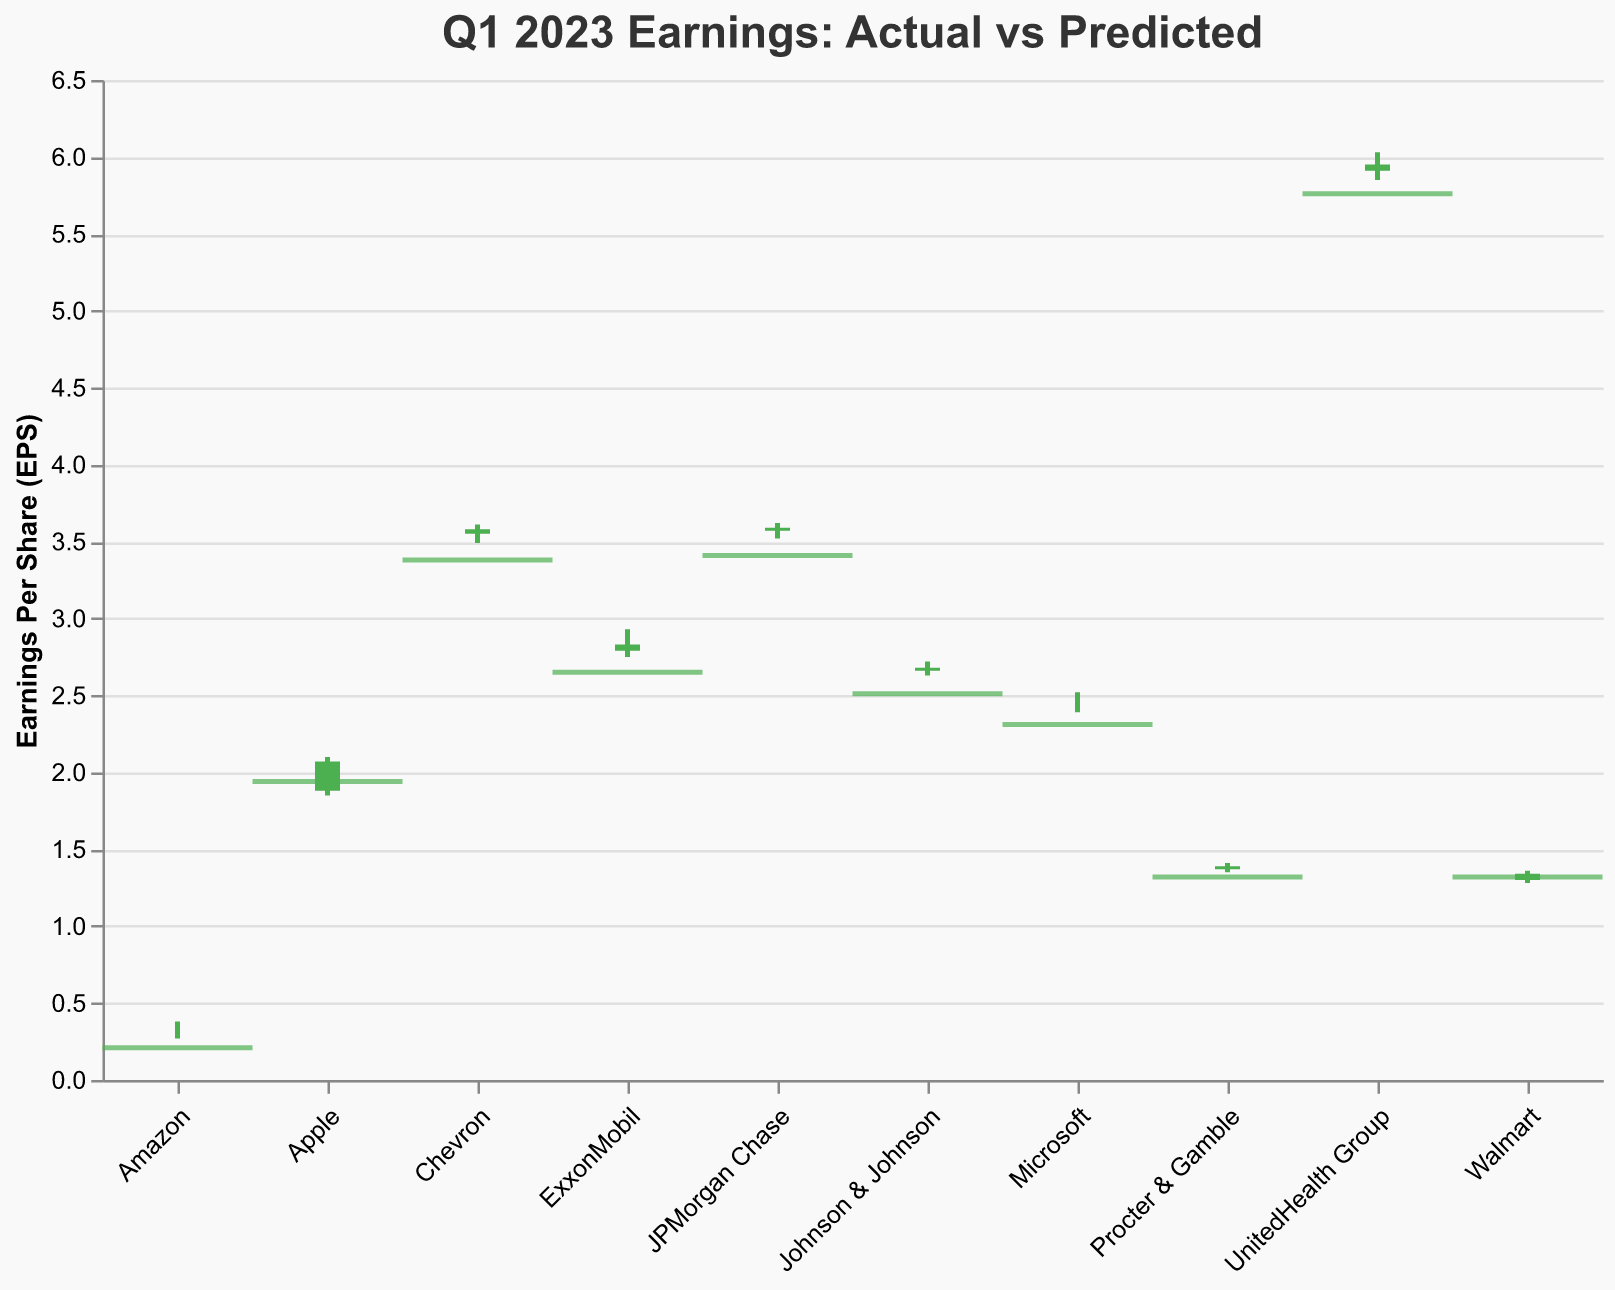How many companies had their actual EPS close higher than their predicted EPS? Identify the companies where the actual close is higher than the predicted EPS by comparing each Actual_Close to the Predicted_EPS. Count the number of such companies.
Answer: 7 What is the difference between the highest and lowest actual open EPS for the listed companies? Determine the highest and lowest values in the Actual_Open column. Subtract the lowest value from the highest value: 5.91 (UnitedHealth Group) - 0.31 (Amazon).
Answer: 5.60 Which company had the smallest range (high minus low) in their actual EPS? Calculate the range (Actual_High - Actual_Low) for each company and identify the company with the smallest value. For Walmart, the range is 1.36 - 1.28 = 0.08.
Answer: Walmart Compare Apple's actual close EPS with its predicted EPS. Was the actual close higher or lower? Compare the Actual_Close (2.07) with the Predicted_EPS (1.94) for Apple. Since 2.07 > 1.94, the actual close was higher.
Answer: Higher What was the average predicted EPS value among all the companies? Sum all the predicted EPS values and divide by the number of companies. The sum is 1.94 + 2.31 + 0.21 + 1.32 + 2.65 + 3.41 + 2.51 + 1.32 + 3.38 + 5.76 = 24.81. There are 10 companies, hence the average is 24.81 / 10 = 2.481.
Answer: 2.48 Which company had the highest actual high EPS in Q1 2023? Look for the maximum value in the Actual_High column and identify the corresponding company. The maximum value is 6.03 (UnitedHealth Group).
Answer: UnitedHealth Group Did any companies close lower than they opened? If so, which ones? Compare the Actual_Open and Actual_Close for each company, and identify those where Actual_Close is less than Actual_Open. No companies had Actual_Close values lower than Actual_Open.
Answer: No What's the difference between the actual close and the predicted EPS for JPMorgan Chase? Subtract the Predicted_EPS (3.41) from the Actual_Close (3.59) for JPMorgan Chase.
Answer: 0.18 Did any company's actual close EPS match their predicted EPS? Compare the Actual_Close and Predicted_EPS for each company to see if any values are equal. No companies have matching values for Actual_Close and Predicted_EPS.
Answer: No 